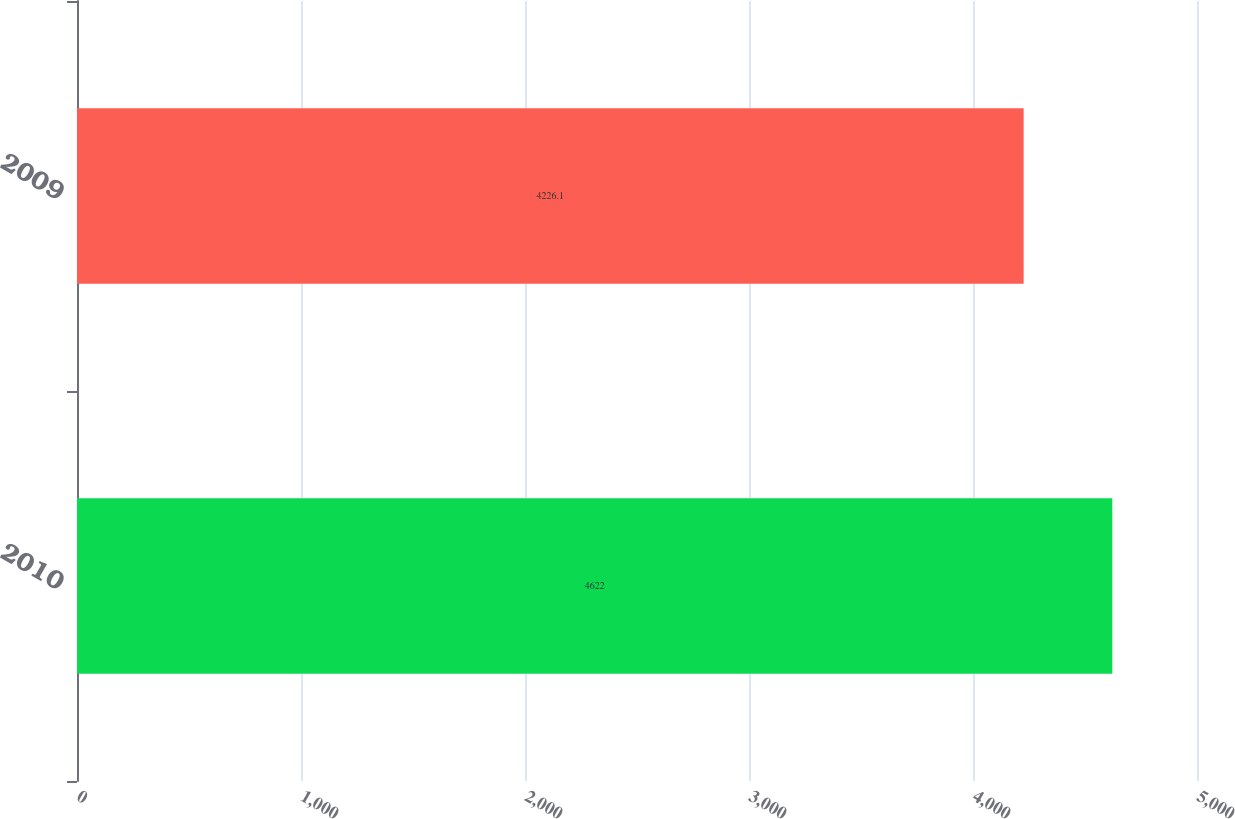Convert chart. <chart><loc_0><loc_0><loc_500><loc_500><bar_chart><fcel>2010<fcel>2009<nl><fcel>4622<fcel>4226.1<nl></chart> 